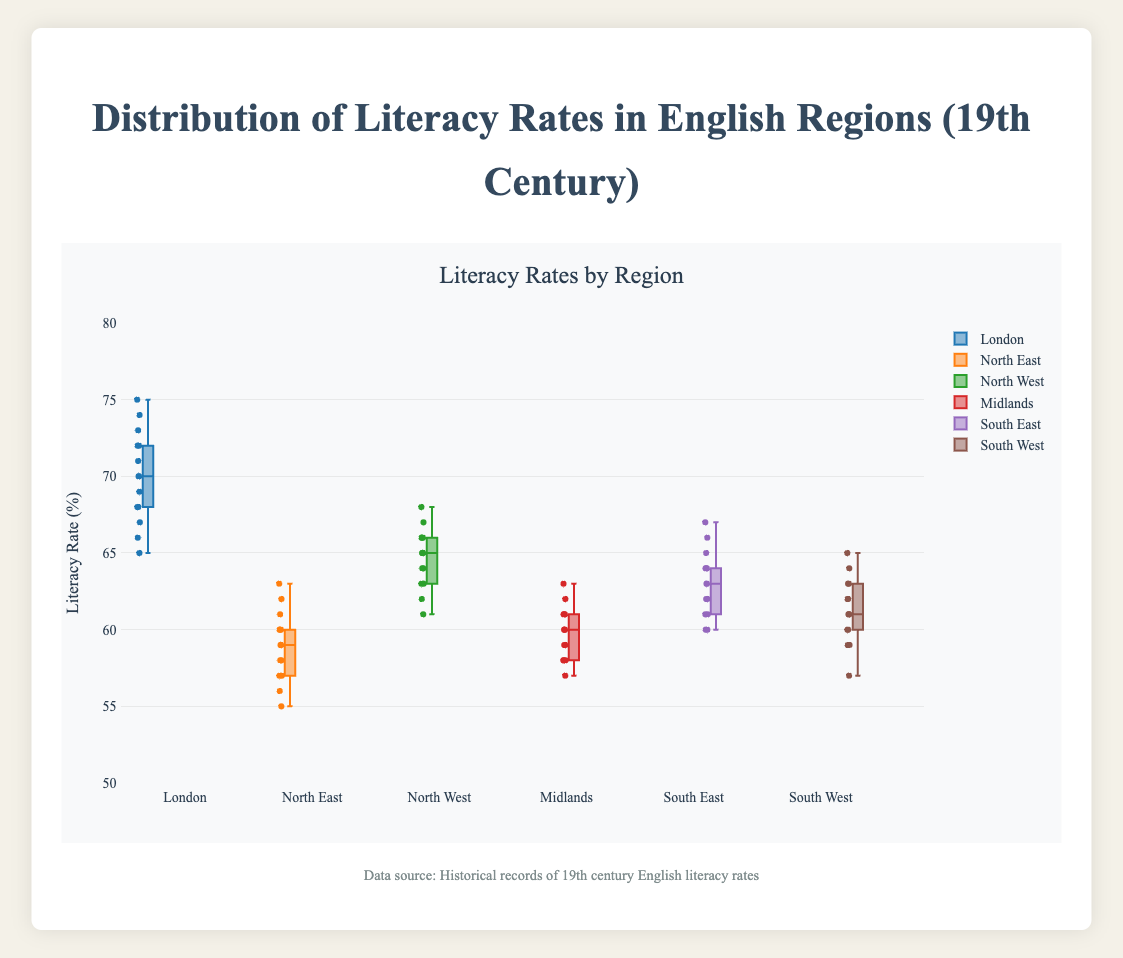What does the title of the plot indicate? The title of the plot is "Distribution of Literacy Rates in English Regions (19th Century)" which indicates that the plot shows how literacy rates were spread across different English regions during the 19th century.
Answer: The title is "Distribution of Literacy Rates in English Regions (19th Century)" What does the y-axis represent? The y-axis is labeled "Literacy Rate (%)" which indicates that it represents the percentage of literacy rates in the different regions.
Answer: Literacy Rate (%) Which region has the highest median literacy rate? The median is the middle value in the box of the box plot. For London, the median appears to be around 70%, which is higher compared to other regions.
Answer: London Which region shows the lowest minimum literacy rate? The minimum value is represented by the lowest point in the box plot. For North East, the minimum is around 55%, which is the lowest among the regions.
Answer: North East What is the interquartile range (IQR) for the Midlands region? The IQR is the range between the first quartile (Q1) and the third quartile (Q3). For Midlands, Q1 is around 58%, and Q3 is around 61%, so IQR = 61 - 58 = 3%.
Answer: 3% How does the interquartile range of North West compare to South East? The IQR for North West is between Q1=63% and Q3=66%, which is 66 - 63 = 3%. For South East, Q1=61% and Q3=64%, which is 64 - 61 = 3%. Both regions have the same IQR.
Answer: They are equal Explain how the outliers are represented in this plot and identify any regions with outliers. Outliers in a box plot are typically shown as individual points outside the whiskers. None of the regions appear to have outliers in their literacy rates data.
Answer: No regions with outliers What is the range of literacy rates for the South West region? The range is the difference between the maximum and minimum values. For South West, minimum is about 57% and maximum is about 65%, so the range is 65 - 57 = 8%.
Answer: 8% Which region shows greater variability in literacy rates, North East or South West? Variability can be judged by the spread of the box and whiskers. The South West's box and whiskers cover a larger range compared to North East.
Answer: South West What statement can you make about the distribution of literacy rates in London compared to other regions? London's distribution has higher median values and less variability in its data, indicating overall higher literacy rates and more consistency within the region compared to others.
Answer: London has higher and more consistent literacy rates 